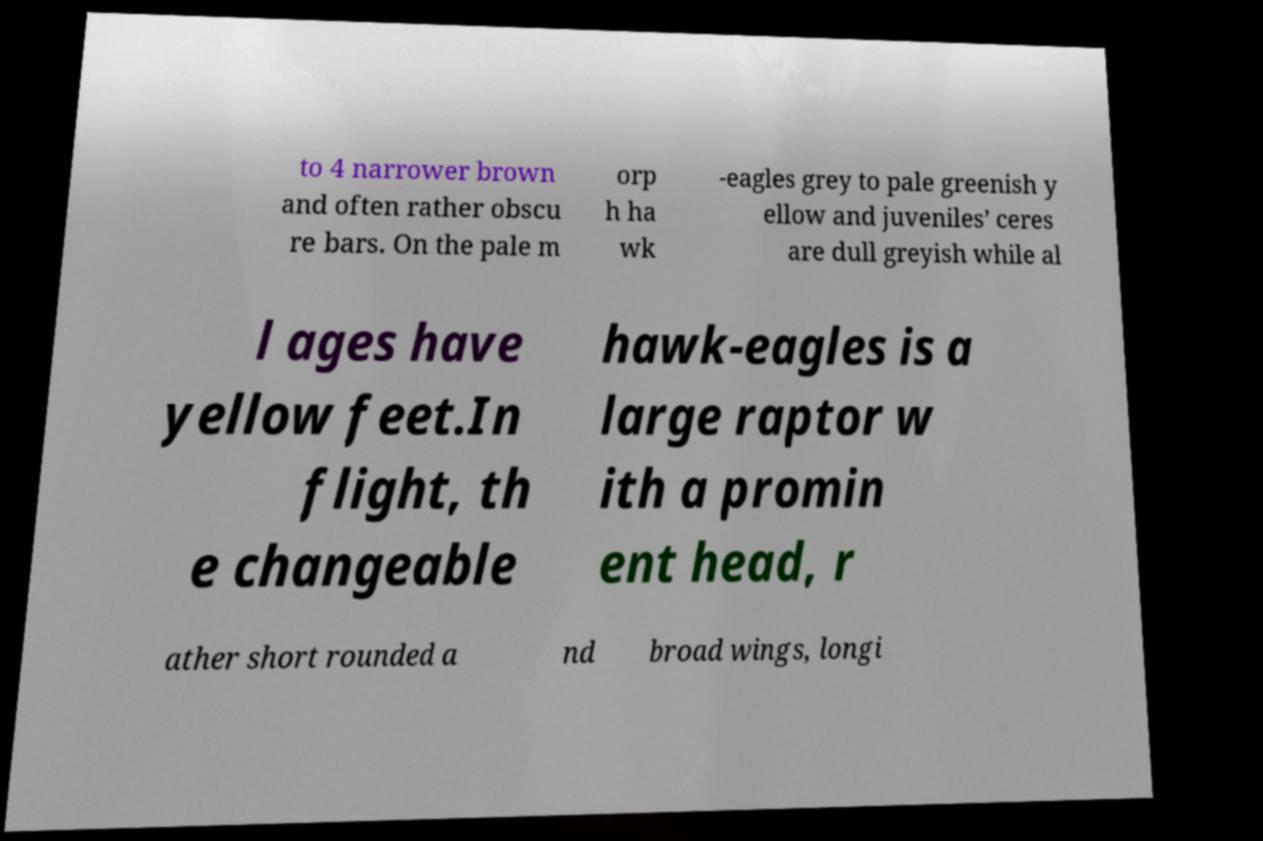Can you read and provide the text displayed in the image?This photo seems to have some interesting text. Can you extract and type it out for me? to 4 narrower brown and often rather obscu re bars. On the pale m orp h ha wk -eagles grey to pale greenish y ellow and juveniles’ ceres are dull greyish while al l ages have yellow feet.In flight, th e changeable hawk-eagles is a large raptor w ith a promin ent head, r ather short rounded a nd broad wings, longi 